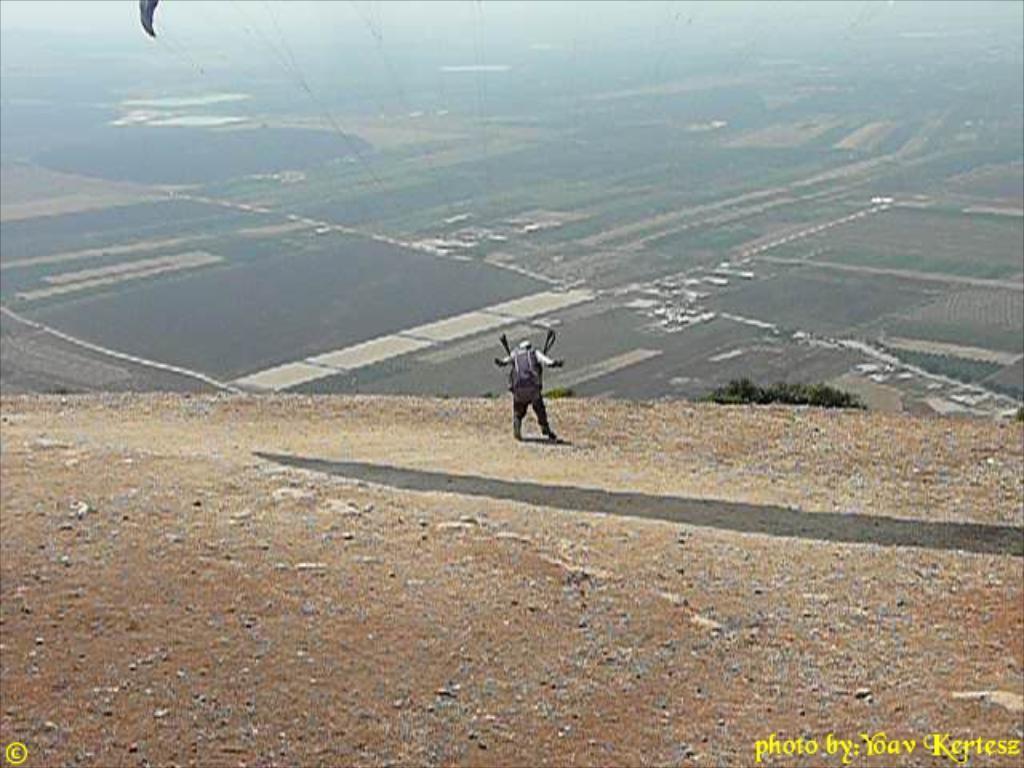Describe this image in one or two sentences. In this picture we can see a person standing on the ground and in the background we can see fields, sky. 